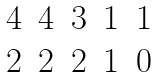Convert formula to latex. <formula><loc_0><loc_0><loc_500><loc_500>\begin{matrix} 4 & 4 & 3 & 1 & 1 \\ 2 & 2 & 2 & 1 & 0 \end{matrix}</formula> 